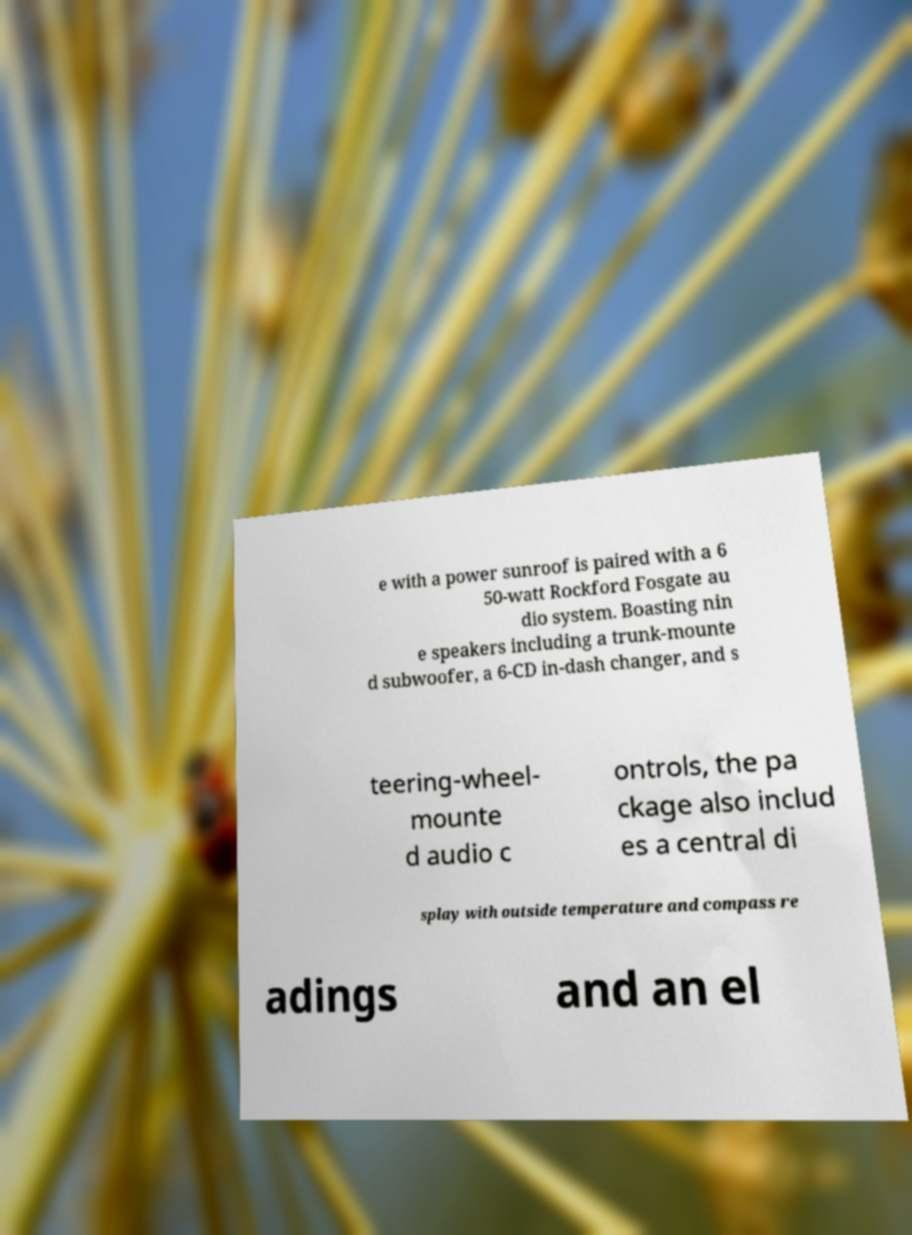Please read and relay the text visible in this image. What does it say? e with a power sunroof is paired with a 6 50-watt Rockford Fosgate au dio system. Boasting nin e speakers including a trunk-mounte d subwoofer, a 6-CD in-dash changer, and s teering-wheel- mounte d audio c ontrols, the pa ckage also includ es a central di splay with outside temperature and compass re adings and an el 